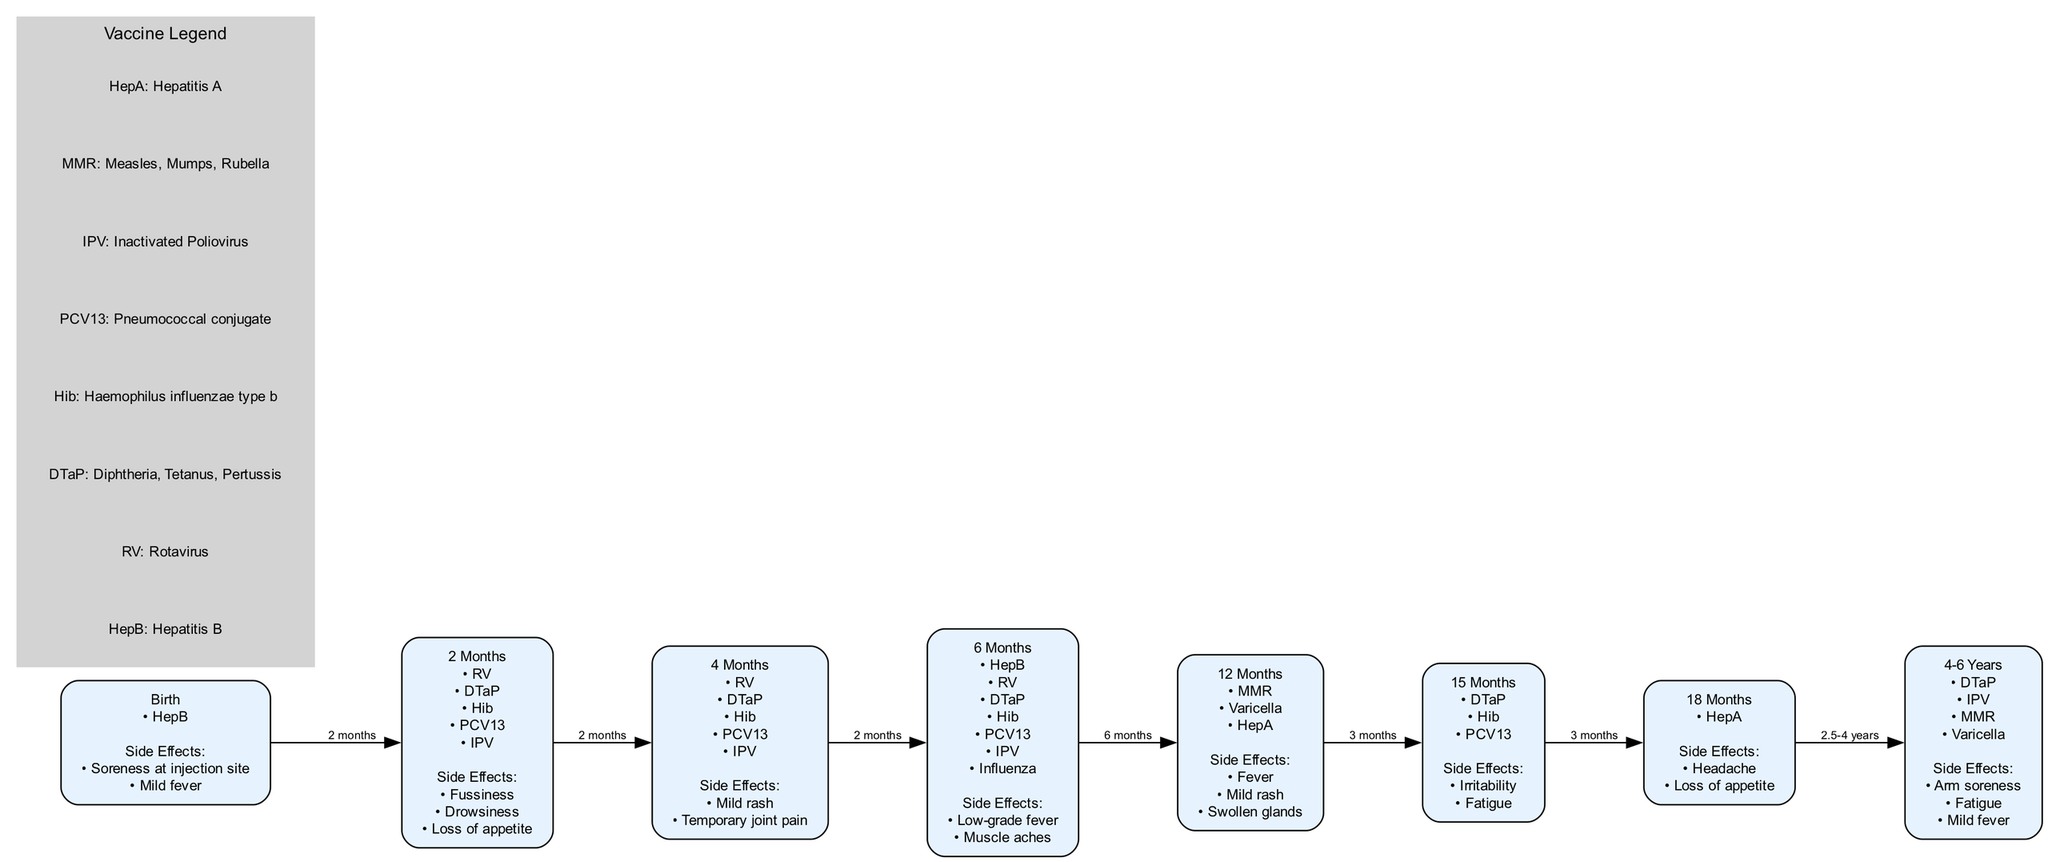What vaccines are given at 12 months? The diagram shows that at 12 months, the vaccines administered are MMR, Varicella, and HepA. These vaccines are listed under the corresponding node labeled "12 Months".
Answer: MMR, Varicella, HepA What are the potential side effects of the vaccine given at 6 months? The node for 6 months indicates that the potential side effects are low-grade fever and muscle aches, which are noted under that specific time frame in the diagram.
Answer: Low-grade fever, Muscle aches How many total vaccination nodes are there in the diagram? By counting the unique nodes listed in the diagram, we find there are a total of 8 nodes, each representing a vaccination point in time from birth to 6 years.
Answer: 8 What is the time gap between vaccinations at 15 months and 18 months? The diagram shows a label indicating that the gap between vaccinations at 15 months and 18 months is 3 months, as specified on the connecting edge between the two nodes.
Answer: 3 months Which vaccines are given between 4 and 6 years? At the node labeled "4-6 Years", the vaccines indicated are DTaP, IPV, MMR, and Varicella. This information is directly listed within the node representing the age range.
Answer: DTaP, IPV, MMR, Varicella What does HepB stand for? The legend specifies that HepB is the abbreviation for Hepatitis B, clearly defining the full name associated with that abbreviation in the vaccination schedule.
Answer: Hepatitis B How many side effects are listed for vaccines at 2 months? The node for 2 months lists three side effects: fussiness, drowsiness, and loss of appetite, which can be counted directly from the details shown underneath that node.
Answer: 3 What is the side effect associated with the HepA vaccine given at 18 months? The diagram indicates that at 18 months, the potential side effects of the HepA vaccine are headache and loss of appetite, as detailed in the corresponding node for that age.
Answer: Headache, Loss of appetite Which vaccination occurs first, HepB or DTaP? Reviewing the vaccination schedule in the diagram, HepB is given at birth while DTaP is first administered at 2 months, so HepB occurs before DTaP.
Answer: HepB 